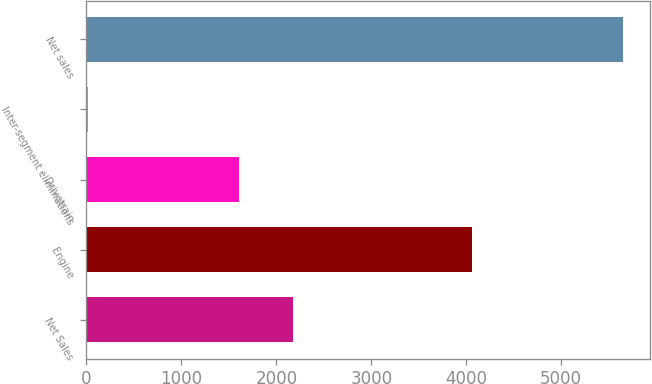<chart> <loc_0><loc_0><loc_500><loc_500><bar_chart><fcel>Net Sales<fcel>Engine<fcel>Drivetrain<fcel>Inter-segment eliminations<fcel>Net sales<nl><fcel>2174.74<fcel>4060.8<fcel>1611.4<fcel>19.4<fcel>5652.8<nl></chart> 